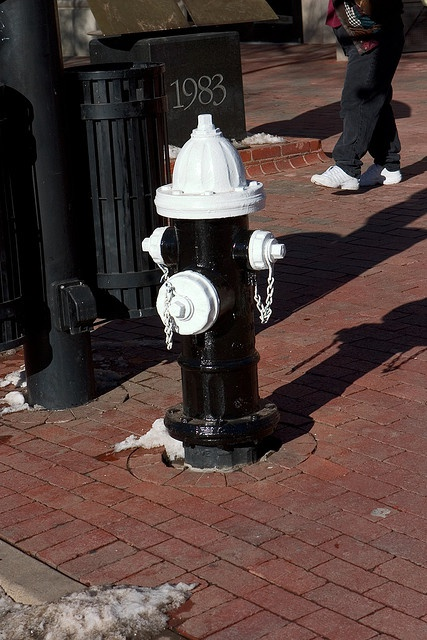Describe the objects in this image and their specific colors. I can see fire hydrant in black, white, gray, and darkgray tones and people in black, lightgray, gray, and maroon tones in this image. 